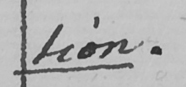What is written in this line of handwriting? tion . 